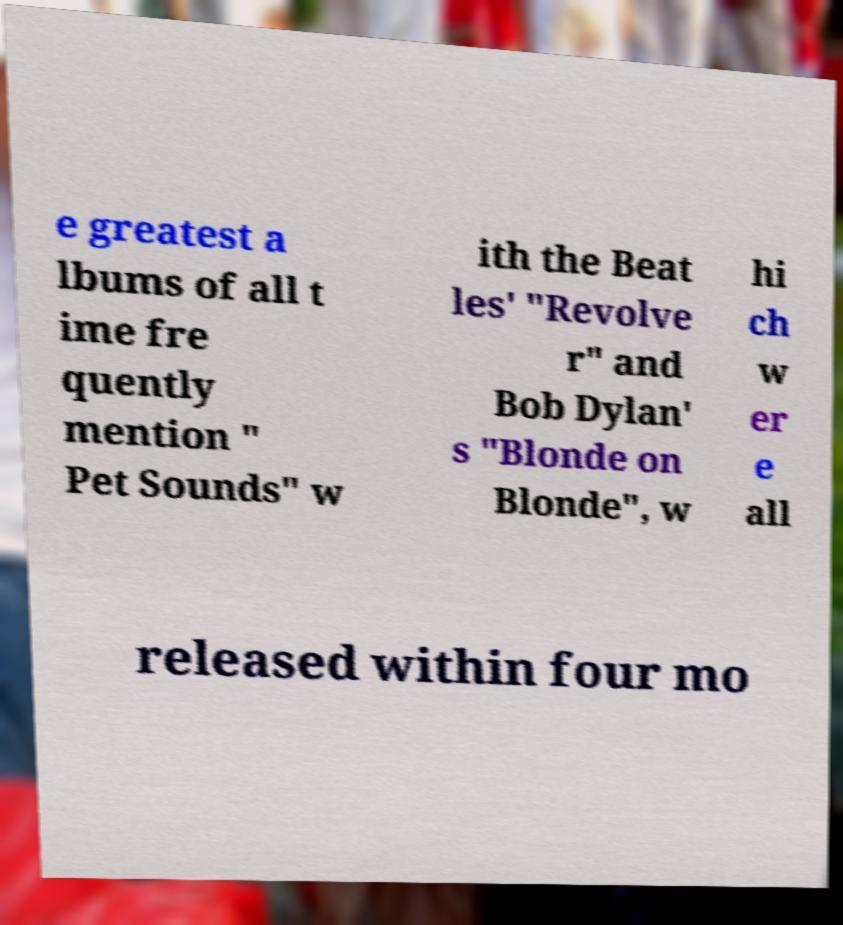For documentation purposes, I need the text within this image transcribed. Could you provide that? e greatest a lbums of all t ime fre quently mention " Pet Sounds" w ith the Beat les' "Revolve r" and Bob Dylan' s "Blonde on Blonde", w hi ch w er e all released within four mo 